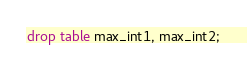<code> <loc_0><loc_0><loc_500><loc_500><_SQL_>


drop table max_int1, max_int2;






</code> 